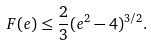<formula> <loc_0><loc_0><loc_500><loc_500>F ( e ) \leq \frac { 2 } { 3 } ( e ^ { 2 } - 4 ) ^ { 3 / 2 } .</formula> 